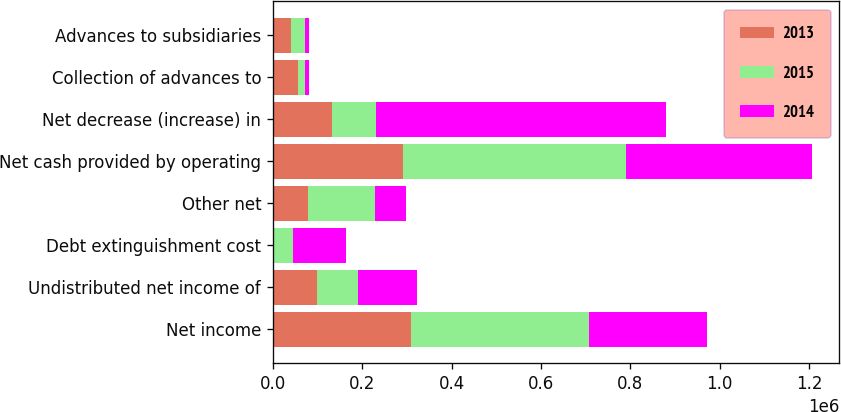Convert chart. <chart><loc_0><loc_0><loc_500><loc_500><stacked_bar_chart><ecel><fcel>Net income<fcel>Undistributed net income of<fcel>Debt extinguishment cost<fcel>Other net<fcel>Net cash provided by operating<fcel>Net decrease (increase) in<fcel>Collection of advances to<fcel>Advances to subsidiaries<nl><fcel>2013<fcel>309471<fcel>97781<fcel>135<fcel>78580<fcel>290405<fcel>132267<fcel>56000<fcel>41000<nl><fcel>2015<fcel>398462<fcel>93163<fcel>44422<fcel>149280<fcel>499001<fcel>97781<fcel>15000<fcel>30060<nl><fcel>2014<fcel>263791<fcel>131642<fcel>120192<fcel>69394<fcel>417372<fcel>650736<fcel>10000<fcel>10000<nl></chart> 